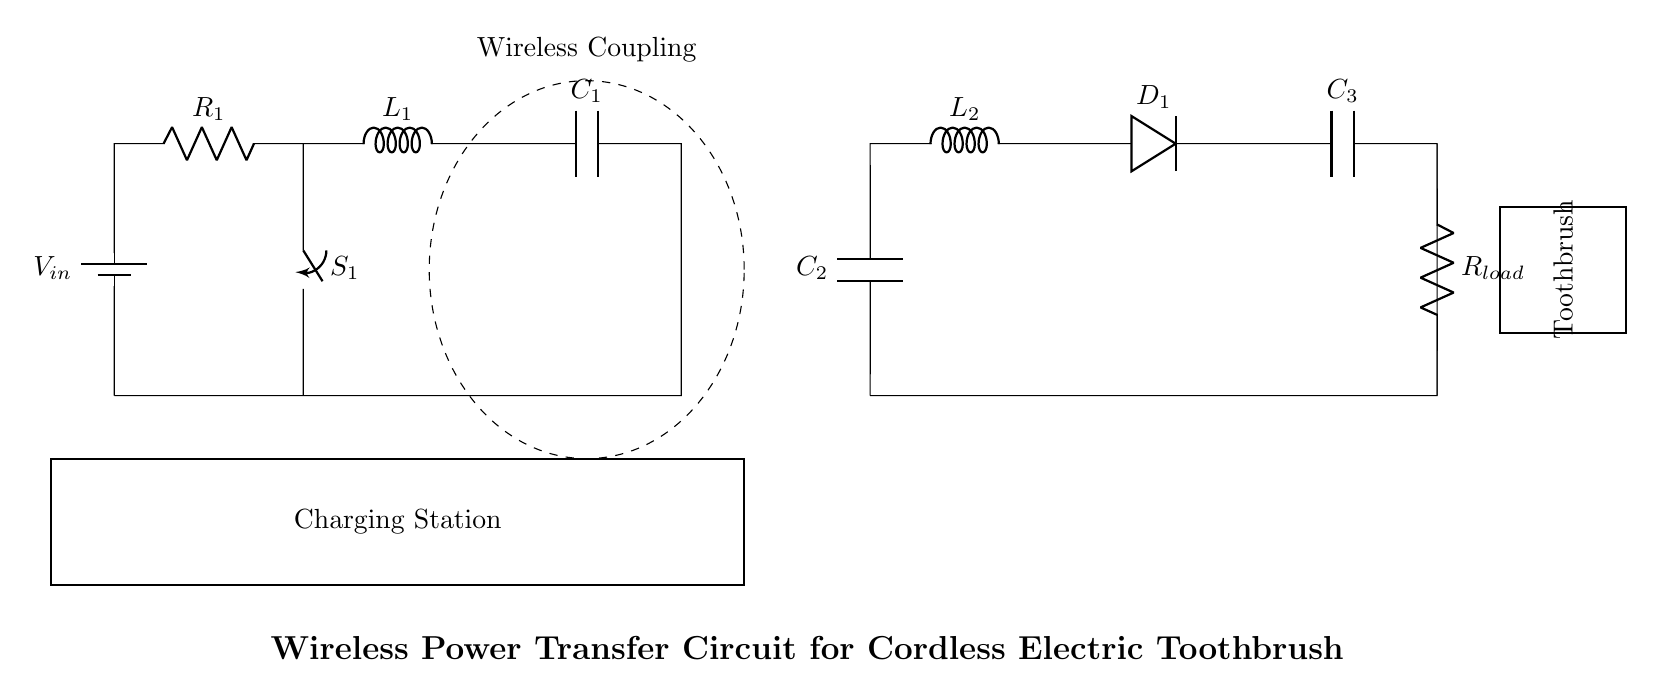What type of power source is used in this circuit? The power source is a battery, indicated by the symbol labeled V_in in the diagram.
Answer: Battery What component represents the load in the circuit? The load is represented by R_load, which is located on the secondary side of the circuit, drawing power to charge the toothbrush.
Answer: R_load What is the function of the switch S_1 in this circuit? The switch S_1 allows for the control of the current flow from the battery to the primary side of the circuit. When closed, it completes the circuit, enabling charging.
Answer: Current control What is the purpose of the dashed ellipse in the circuit diagram? The dashed ellipse indicates the wireless coupling area that transfers energy from the primary side to the secondary side without physical connections, which is essential for this wireless charging design.
Answer: Wireless coupling How many capacitors are present in the circuit? There are three capacitors in the circuit: C_1 and C_2 on the primary and secondary sides, respectively, and C_3 on the secondary side as well.
Answer: Three What kind of load does this circuit specifically aim to charge? The circuit is designed to charge a cordless electric toothbrush, which is clearly labeled in the diagram as the device receiving power.
Answer: Toothbrush What are the components on the primary side of the circuit? The primary side consists of a battery (V_in), a resistor (R_1), an inductor (L_1), a capacitor (C_1), and a switch (S_1).
Answer: Battery, resistor, inductor, capacitor, switch 